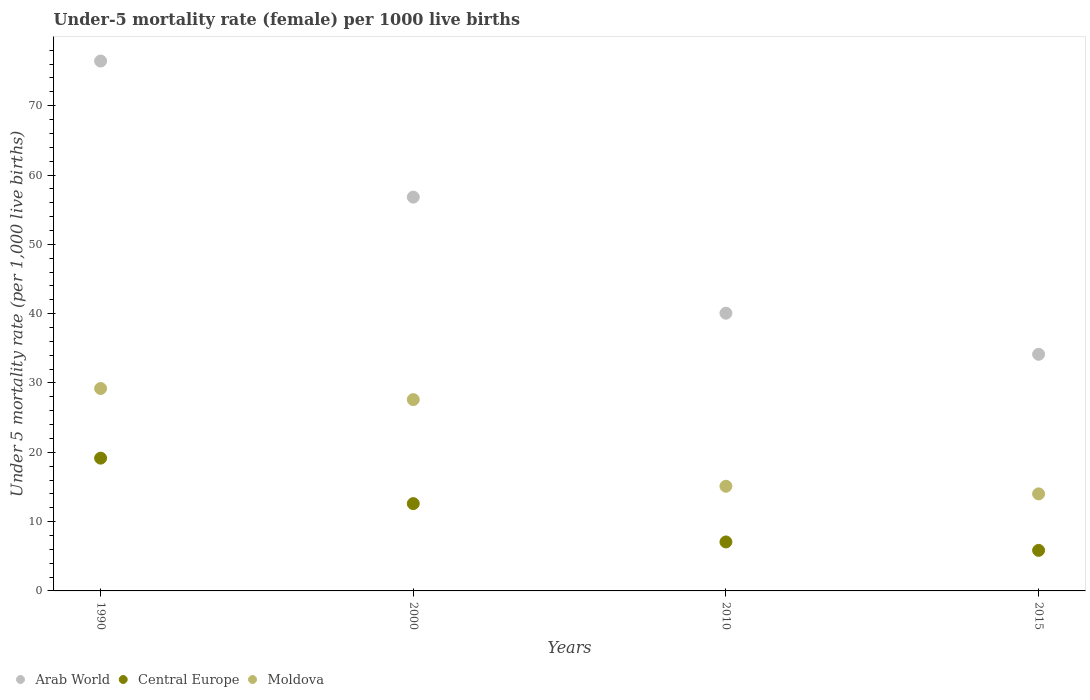Across all years, what is the maximum under-five mortality rate in Central Europe?
Make the answer very short. 19.15. Across all years, what is the minimum under-five mortality rate in Moldova?
Offer a very short reply. 14. In which year was the under-five mortality rate in Arab World minimum?
Your response must be concise. 2015. What is the total under-five mortality rate in Central Europe in the graph?
Give a very brief answer. 44.66. What is the difference between the under-five mortality rate in Moldova in 2000 and that in 2010?
Offer a very short reply. 12.5. What is the difference between the under-five mortality rate in Arab World in 1990 and the under-five mortality rate in Central Europe in 2010?
Give a very brief answer. 69.38. What is the average under-five mortality rate in Central Europe per year?
Offer a terse response. 11.17. In the year 2000, what is the difference between the under-five mortality rate in Moldova and under-five mortality rate in Arab World?
Give a very brief answer. -29.21. In how many years, is the under-five mortality rate in Central Europe greater than 46?
Your answer should be very brief. 0. What is the ratio of the under-five mortality rate in Arab World in 1990 to that in 2010?
Provide a succinct answer. 1.91. Is the under-five mortality rate in Central Europe in 1990 less than that in 2000?
Provide a short and direct response. No. What is the difference between the highest and the second highest under-five mortality rate in Arab World?
Give a very brief answer. 19.63. What is the difference between the highest and the lowest under-five mortality rate in Arab World?
Your response must be concise. 42.3. Does the under-five mortality rate in Arab World monotonically increase over the years?
Your response must be concise. No. Does the graph contain any zero values?
Offer a terse response. No. Where does the legend appear in the graph?
Keep it short and to the point. Bottom left. How many legend labels are there?
Provide a succinct answer. 3. What is the title of the graph?
Keep it short and to the point. Under-5 mortality rate (female) per 1000 live births. What is the label or title of the X-axis?
Your answer should be very brief. Years. What is the label or title of the Y-axis?
Ensure brevity in your answer.  Under 5 mortality rate (per 1,0 live births). What is the Under 5 mortality rate (per 1,000 live births) in Arab World in 1990?
Give a very brief answer. 76.44. What is the Under 5 mortality rate (per 1,000 live births) of Central Europe in 1990?
Your response must be concise. 19.15. What is the Under 5 mortality rate (per 1,000 live births) in Moldova in 1990?
Your answer should be very brief. 29.2. What is the Under 5 mortality rate (per 1,000 live births) in Arab World in 2000?
Ensure brevity in your answer.  56.81. What is the Under 5 mortality rate (per 1,000 live births) in Central Europe in 2000?
Provide a succinct answer. 12.6. What is the Under 5 mortality rate (per 1,000 live births) of Moldova in 2000?
Offer a very short reply. 27.6. What is the Under 5 mortality rate (per 1,000 live births) in Arab World in 2010?
Your answer should be compact. 40.06. What is the Under 5 mortality rate (per 1,000 live births) in Central Europe in 2010?
Your answer should be compact. 7.06. What is the Under 5 mortality rate (per 1,000 live births) in Moldova in 2010?
Provide a succinct answer. 15.1. What is the Under 5 mortality rate (per 1,000 live births) in Arab World in 2015?
Your answer should be compact. 34.14. What is the Under 5 mortality rate (per 1,000 live births) of Central Europe in 2015?
Make the answer very short. 5.85. What is the Under 5 mortality rate (per 1,000 live births) of Moldova in 2015?
Offer a very short reply. 14. Across all years, what is the maximum Under 5 mortality rate (per 1,000 live births) in Arab World?
Offer a terse response. 76.44. Across all years, what is the maximum Under 5 mortality rate (per 1,000 live births) of Central Europe?
Give a very brief answer. 19.15. Across all years, what is the maximum Under 5 mortality rate (per 1,000 live births) of Moldova?
Your answer should be compact. 29.2. Across all years, what is the minimum Under 5 mortality rate (per 1,000 live births) in Arab World?
Offer a very short reply. 34.14. Across all years, what is the minimum Under 5 mortality rate (per 1,000 live births) of Central Europe?
Make the answer very short. 5.85. Across all years, what is the minimum Under 5 mortality rate (per 1,000 live births) in Moldova?
Your response must be concise. 14. What is the total Under 5 mortality rate (per 1,000 live births) in Arab World in the graph?
Ensure brevity in your answer.  207.45. What is the total Under 5 mortality rate (per 1,000 live births) in Central Europe in the graph?
Your answer should be compact. 44.66. What is the total Under 5 mortality rate (per 1,000 live births) in Moldova in the graph?
Your answer should be compact. 85.9. What is the difference between the Under 5 mortality rate (per 1,000 live births) of Arab World in 1990 and that in 2000?
Your response must be concise. 19.63. What is the difference between the Under 5 mortality rate (per 1,000 live births) in Central Europe in 1990 and that in 2000?
Offer a terse response. 6.56. What is the difference between the Under 5 mortality rate (per 1,000 live births) in Moldova in 1990 and that in 2000?
Your answer should be compact. 1.6. What is the difference between the Under 5 mortality rate (per 1,000 live births) of Arab World in 1990 and that in 2010?
Provide a short and direct response. 36.38. What is the difference between the Under 5 mortality rate (per 1,000 live births) of Central Europe in 1990 and that in 2010?
Your response must be concise. 12.09. What is the difference between the Under 5 mortality rate (per 1,000 live births) in Arab World in 1990 and that in 2015?
Offer a terse response. 42.3. What is the difference between the Under 5 mortality rate (per 1,000 live births) in Central Europe in 1990 and that in 2015?
Your answer should be very brief. 13.3. What is the difference between the Under 5 mortality rate (per 1,000 live births) of Moldova in 1990 and that in 2015?
Provide a short and direct response. 15.2. What is the difference between the Under 5 mortality rate (per 1,000 live births) of Arab World in 2000 and that in 2010?
Offer a terse response. 16.74. What is the difference between the Under 5 mortality rate (per 1,000 live births) in Central Europe in 2000 and that in 2010?
Make the answer very short. 5.53. What is the difference between the Under 5 mortality rate (per 1,000 live births) in Moldova in 2000 and that in 2010?
Your answer should be very brief. 12.5. What is the difference between the Under 5 mortality rate (per 1,000 live births) in Arab World in 2000 and that in 2015?
Give a very brief answer. 22.67. What is the difference between the Under 5 mortality rate (per 1,000 live births) in Central Europe in 2000 and that in 2015?
Make the answer very short. 6.74. What is the difference between the Under 5 mortality rate (per 1,000 live births) of Arab World in 2010 and that in 2015?
Your response must be concise. 5.93. What is the difference between the Under 5 mortality rate (per 1,000 live births) in Central Europe in 2010 and that in 2015?
Make the answer very short. 1.21. What is the difference between the Under 5 mortality rate (per 1,000 live births) of Moldova in 2010 and that in 2015?
Ensure brevity in your answer.  1.1. What is the difference between the Under 5 mortality rate (per 1,000 live births) of Arab World in 1990 and the Under 5 mortality rate (per 1,000 live births) of Central Europe in 2000?
Offer a terse response. 63.84. What is the difference between the Under 5 mortality rate (per 1,000 live births) in Arab World in 1990 and the Under 5 mortality rate (per 1,000 live births) in Moldova in 2000?
Your answer should be compact. 48.84. What is the difference between the Under 5 mortality rate (per 1,000 live births) of Central Europe in 1990 and the Under 5 mortality rate (per 1,000 live births) of Moldova in 2000?
Provide a succinct answer. -8.45. What is the difference between the Under 5 mortality rate (per 1,000 live births) of Arab World in 1990 and the Under 5 mortality rate (per 1,000 live births) of Central Europe in 2010?
Keep it short and to the point. 69.38. What is the difference between the Under 5 mortality rate (per 1,000 live births) in Arab World in 1990 and the Under 5 mortality rate (per 1,000 live births) in Moldova in 2010?
Your answer should be compact. 61.34. What is the difference between the Under 5 mortality rate (per 1,000 live births) in Central Europe in 1990 and the Under 5 mortality rate (per 1,000 live births) in Moldova in 2010?
Provide a succinct answer. 4.05. What is the difference between the Under 5 mortality rate (per 1,000 live births) of Arab World in 1990 and the Under 5 mortality rate (per 1,000 live births) of Central Europe in 2015?
Keep it short and to the point. 70.59. What is the difference between the Under 5 mortality rate (per 1,000 live births) in Arab World in 1990 and the Under 5 mortality rate (per 1,000 live births) in Moldova in 2015?
Make the answer very short. 62.44. What is the difference between the Under 5 mortality rate (per 1,000 live births) in Central Europe in 1990 and the Under 5 mortality rate (per 1,000 live births) in Moldova in 2015?
Your response must be concise. 5.15. What is the difference between the Under 5 mortality rate (per 1,000 live births) of Arab World in 2000 and the Under 5 mortality rate (per 1,000 live births) of Central Europe in 2010?
Provide a succinct answer. 49.74. What is the difference between the Under 5 mortality rate (per 1,000 live births) of Arab World in 2000 and the Under 5 mortality rate (per 1,000 live births) of Moldova in 2010?
Your response must be concise. 41.71. What is the difference between the Under 5 mortality rate (per 1,000 live births) of Central Europe in 2000 and the Under 5 mortality rate (per 1,000 live births) of Moldova in 2010?
Offer a terse response. -2.5. What is the difference between the Under 5 mortality rate (per 1,000 live births) of Arab World in 2000 and the Under 5 mortality rate (per 1,000 live births) of Central Europe in 2015?
Offer a terse response. 50.96. What is the difference between the Under 5 mortality rate (per 1,000 live births) in Arab World in 2000 and the Under 5 mortality rate (per 1,000 live births) in Moldova in 2015?
Give a very brief answer. 42.81. What is the difference between the Under 5 mortality rate (per 1,000 live births) of Central Europe in 2000 and the Under 5 mortality rate (per 1,000 live births) of Moldova in 2015?
Offer a terse response. -1.4. What is the difference between the Under 5 mortality rate (per 1,000 live births) in Arab World in 2010 and the Under 5 mortality rate (per 1,000 live births) in Central Europe in 2015?
Offer a very short reply. 34.21. What is the difference between the Under 5 mortality rate (per 1,000 live births) of Arab World in 2010 and the Under 5 mortality rate (per 1,000 live births) of Moldova in 2015?
Provide a short and direct response. 26.06. What is the difference between the Under 5 mortality rate (per 1,000 live births) of Central Europe in 2010 and the Under 5 mortality rate (per 1,000 live births) of Moldova in 2015?
Make the answer very short. -6.94. What is the average Under 5 mortality rate (per 1,000 live births) of Arab World per year?
Offer a very short reply. 51.86. What is the average Under 5 mortality rate (per 1,000 live births) in Central Europe per year?
Ensure brevity in your answer.  11.17. What is the average Under 5 mortality rate (per 1,000 live births) in Moldova per year?
Your response must be concise. 21.48. In the year 1990, what is the difference between the Under 5 mortality rate (per 1,000 live births) in Arab World and Under 5 mortality rate (per 1,000 live births) in Central Europe?
Give a very brief answer. 57.29. In the year 1990, what is the difference between the Under 5 mortality rate (per 1,000 live births) in Arab World and Under 5 mortality rate (per 1,000 live births) in Moldova?
Keep it short and to the point. 47.24. In the year 1990, what is the difference between the Under 5 mortality rate (per 1,000 live births) in Central Europe and Under 5 mortality rate (per 1,000 live births) in Moldova?
Provide a succinct answer. -10.05. In the year 2000, what is the difference between the Under 5 mortality rate (per 1,000 live births) of Arab World and Under 5 mortality rate (per 1,000 live births) of Central Europe?
Provide a short and direct response. 44.21. In the year 2000, what is the difference between the Under 5 mortality rate (per 1,000 live births) of Arab World and Under 5 mortality rate (per 1,000 live births) of Moldova?
Ensure brevity in your answer.  29.21. In the year 2000, what is the difference between the Under 5 mortality rate (per 1,000 live births) of Central Europe and Under 5 mortality rate (per 1,000 live births) of Moldova?
Your answer should be very brief. -15. In the year 2010, what is the difference between the Under 5 mortality rate (per 1,000 live births) in Arab World and Under 5 mortality rate (per 1,000 live births) in Central Europe?
Your answer should be compact. 33. In the year 2010, what is the difference between the Under 5 mortality rate (per 1,000 live births) in Arab World and Under 5 mortality rate (per 1,000 live births) in Moldova?
Provide a succinct answer. 24.96. In the year 2010, what is the difference between the Under 5 mortality rate (per 1,000 live births) of Central Europe and Under 5 mortality rate (per 1,000 live births) of Moldova?
Offer a terse response. -8.04. In the year 2015, what is the difference between the Under 5 mortality rate (per 1,000 live births) of Arab World and Under 5 mortality rate (per 1,000 live births) of Central Europe?
Your answer should be very brief. 28.29. In the year 2015, what is the difference between the Under 5 mortality rate (per 1,000 live births) in Arab World and Under 5 mortality rate (per 1,000 live births) in Moldova?
Offer a very short reply. 20.14. In the year 2015, what is the difference between the Under 5 mortality rate (per 1,000 live births) in Central Europe and Under 5 mortality rate (per 1,000 live births) in Moldova?
Provide a succinct answer. -8.15. What is the ratio of the Under 5 mortality rate (per 1,000 live births) in Arab World in 1990 to that in 2000?
Give a very brief answer. 1.35. What is the ratio of the Under 5 mortality rate (per 1,000 live births) of Central Europe in 1990 to that in 2000?
Provide a short and direct response. 1.52. What is the ratio of the Under 5 mortality rate (per 1,000 live births) in Moldova in 1990 to that in 2000?
Make the answer very short. 1.06. What is the ratio of the Under 5 mortality rate (per 1,000 live births) in Arab World in 1990 to that in 2010?
Provide a short and direct response. 1.91. What is the ratio of the Under 5 mortality rate (per 1,000 live births) of Central Europe in 1990 to that in 2010?
Offer a terse response. 2.71. What is the ratio of the Under 5 mortality rate (per 1,000 live births) of Moldova in 1990 to that in 2010?
Provide a succinct answer. 1.93. What is the ratio of the Under 5 mortality rate (per 1,000 live births) in Arab World in 1990 to that in 2015?
Keep it short and to the point. 2.24. What is the ratio of the Under 5 mortality rate (per 1,000 live births) of Central Europe in 1990 to that in 2015?
Your answer should be compact. 3.27. What is the ratio of the Under 5 mortality rate (per 1,000 live births) in Moldova in 1990 to that in 2015?
Offer a terse response. 2.09. What is the ratio of the Under 5 mortality rate (per 1,000 live births) of Arab World in 2000 to that in 2010?
Your answer should be very brief. 1.42. What is the ratio of the Under 5 mortality rate (per 1,000 live births) in Central Europe in 2000 to that in 2010?
Keep it short and to the point. 1.78. What is the ratio of the Under 5 mortality rate (per 1,000 live births) of Moldova in 2000 to that in 2010?
Make the answer very short. 1.83. What is the ratio of the Under 5 mortality rate (per 1,000 live births) of Arab World in 2000 to that in 2015?
Keep it short and to the point. 1.66. What is the ratio of the Under 5 mortality rate (per 1,000 live births) in Central Europe in 2000 to that in 2015?
Give a very brief answer. 2.15. What is the ratio of the Under 5 mortality rate (per 1,000 live births) in Moldova in 2000 to that in 2015?
Your answer should be compact. 1.97. What is the ratio of the Under 5 mortality rate (per 1,000 live births) of Arab World in 2010 to that in 2015?
Your answer should be compact. 1.17. What is the ratio of the Under 5 mortality rate (per 1,000 live births) in Central Europe in 2010 to that in 2015?
Provide a short and direct response. 1.21. What is the ratio of the Under 5 mortality rate (per 1,000 live births) in Moldova in 2010 to that in 2015?
Keep it short and to the point. 1.08. What is the difference between the highest and the second highest Under 5 mortality rate (per 1,000 live births) of Arab World?
Offer a terse response. 19.63. What is the difference between the highest and the second highest Under 5 mortality rate (per 1,000 live births) of Central Europe?
Offer a very short reply. 6.56. What is the difference between the highest and the lowest Under 5 mortality rate (per 1,000 live births) in Arab World?
Ensure brevity in your answer.  42.3. What is the difference between the highest and the lowest Under 5 mortality rate (per 1,000 live births) in Central Europe?
Ensure brevity in your answer.  13.3. 